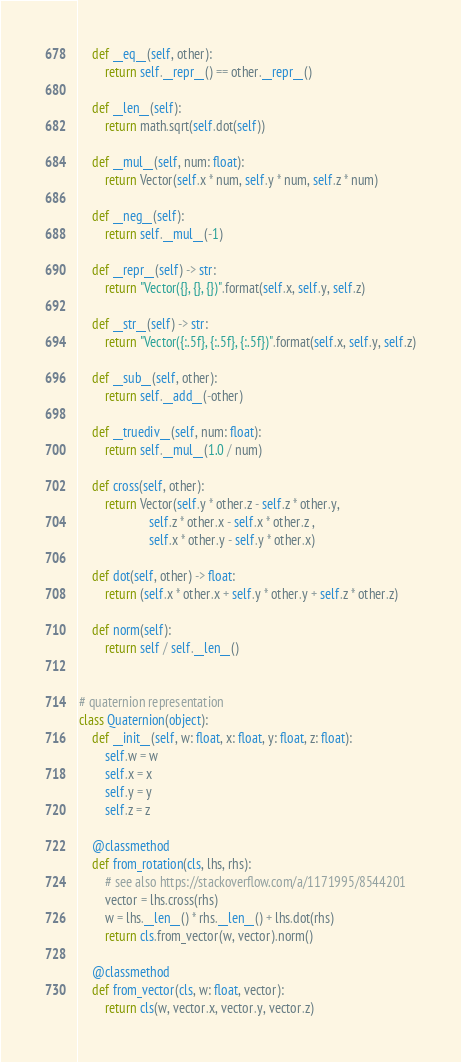<code> <loc_0><loc_0><loc_500><loc_500><_Python_>    def __eq__(self, other):
        return self.__repr__() == other.__repr__()

    def __len__(self):
        return math.sqrt(self.dot(self))

    def __mul__(self, num: float):
        return Vector(self.x * num, self.y * num, self.z * num)

    def __neg__(self):
        return self.__mul__(-1)

    def __repr__(self) -> str:
        return "Vector({}, {}, {})".format(self.x, self.y, self.z)

    def __str__(self) -> str:
        return "Vector({:.5f}, {:.5f}, {:.5f})".format(self.x, self.y, self.z)

    def __sub__(self, other):
        return self.__add__(-other)

    def __truediv__(self, num: float):
        return self.__mul__(1.0 / num)

    def cross(self, other):
        return Vector(self.y * other.z - self.z * other.y,
                      self.z * other.x - self.x * other.z ,
                      self.x * other.y - self.y * other.x)

    def dot(self, other) -> float:
        return (self.x * other.x + self.y * other.y + self.z * other.z)

    def norm(self):
        return self / self.__len__()


# quaternion representation
class Quaternion(object):
    def __init__(self, w: float, x: float, y: float, z: float):
        self.w = w
        self.x = x
        self.y = y
        self.z = z

    @classmethod
    def from_rotation(cls, lhs, rhs):
        # see also https://stackoverflow.com/a/1171995/8544201
        vector = lhs.cross(rhs)
        w = lhs.__len__() * rhs.__len__() + lhs.dot(rhs)
        return cls.from_vector(w, vector).norm()

    @classmethod
    def from_vector(cls, w: float, vector):
        return cls(w, vector.x, vector.y, vector.z)
</code> 